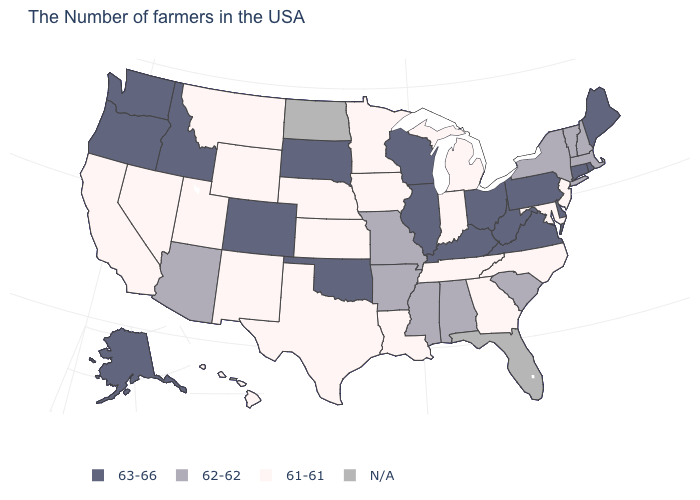Which states have the highest value in the USA?
Keep it brief. Maine, Rhode Island, Connecticut, Delaware, Pennsylvania, Virginia, West Virginia, Ohio, Kentucky, Wisconsin, Illinois, Oklahoma, South Dakota, Colorado, Idaho, Washington, Oregon, Alaska. What is the value of Pennsylvania?
Short answer required. 63-66. What is the value of West Virginia?
Short answer required. 63-66. Which states have the lowest value in the West?
Concise answer only. Wyoming, New Mexico, Utah, Montana, Nevada, California, Hawaii. What is the highest value in the USA?
Write a very short answer. 63-66. Name the states that have a value in the range 62-62?
Concise answer only. Massachusetts, New Hampshire, Vermont, New York, South Carolina, Alabama, Mississippi, Missouri, Arkansas, Arizona. Does the map have missing data?
Short answer required. Yes. Among the states that border Massachusetts , which have the highest value?
Concise answer only. Rhode Island, Connecticut. Which states have the highest value in the USA?
Quick response, please. Maine, Rhode Island, Connecticut, Delaware, Pennsylvania, Virginia, West Virginia, Ohio, Kentucky, Wisconsin, Illinois, Oklahoma, South Dakota, Colorado, Idaho, Washington, Oregon, Alaska. Name the states that have a value in the range 63-66?
Quick response, please. Maine, Rhode Island, Connecticut, Delaware, Pennsylvania, Virginia, West Virginia, Ohio, Kentucky, Wisconsin, Illinois, Oklahoma, South Dakota, Colorado, Idaho, Washington, Oregon, Alaska. What is the lowest value in the MidWest?
Concise answer only. 61-61. Does West Virginia have the highest value in the USA?
Give a very brief answer. Yes. 